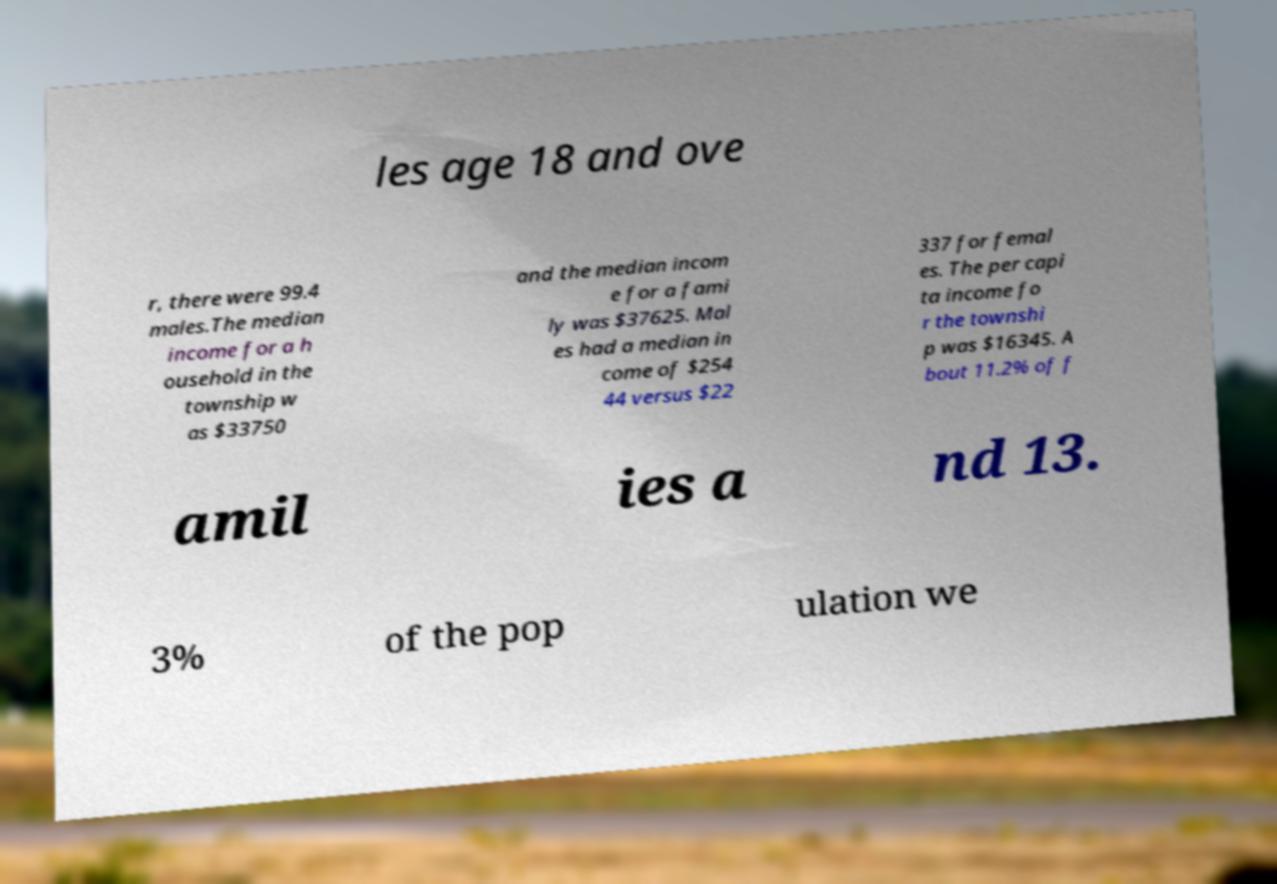What messages or text are displayed in this image? I need them in a readable, typed format. les age 18 and ove r, there were 99.4 males.The median income for a h ousehold in the township w as $33750 and the median incom e for a fami ly was $37625. Mal es had a median in come of $254 44 versus $22 337 for femal es. The per capi ta income fo r the townshi p was $16345. A bout 11.2% of f amil ies a nd 13. 3% of the pop ulation we 